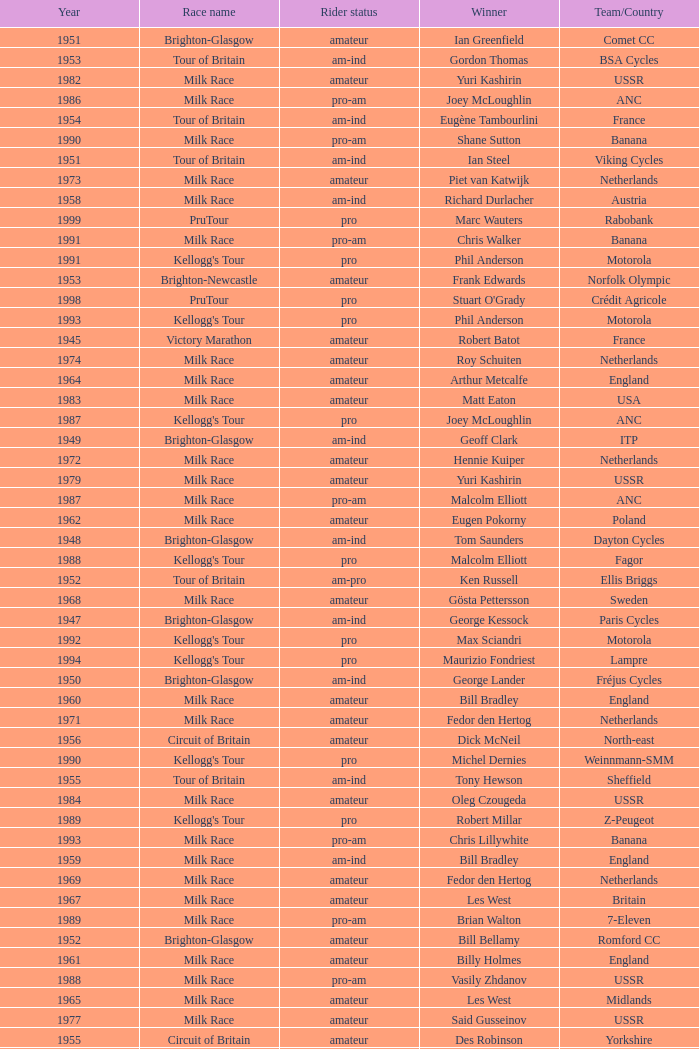What ream played later than 1958 in the kellogg's tour? ANC, Fagor, Z-Peugeot, Weinnmann-SMM, Motorola, Motorola, Motorola, Lampre. 